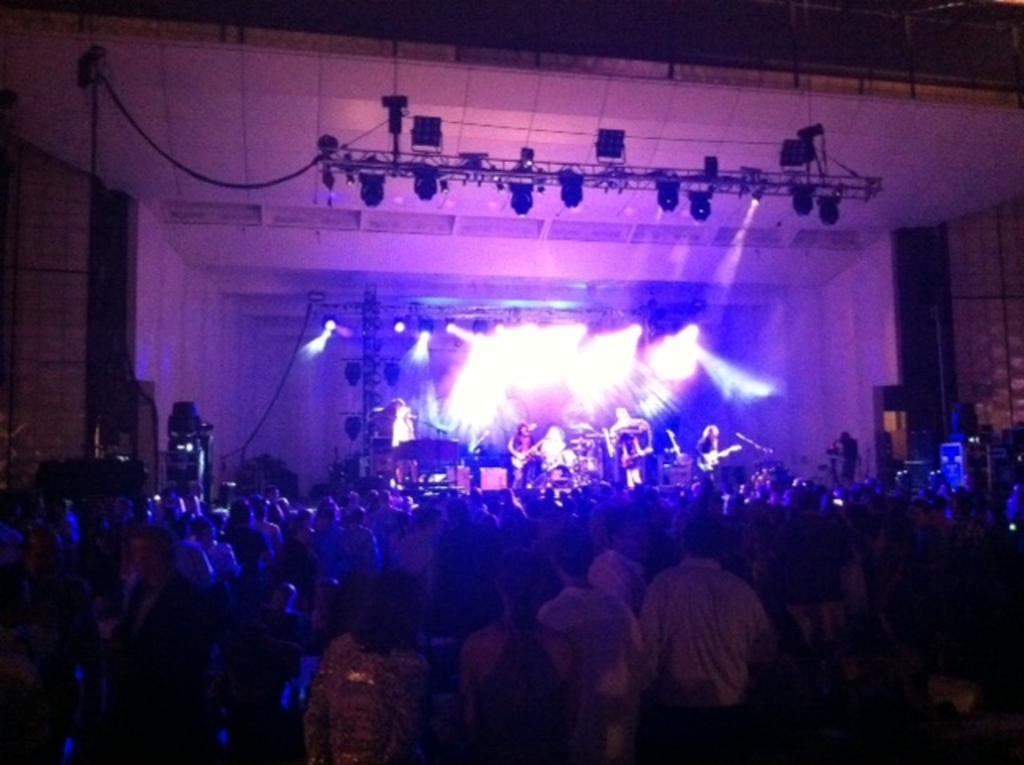Can you describe this image briefly? In this picture we can see some people are standing in the front, there are some people playing musical instruments in the background, we can also see lights in the background. 